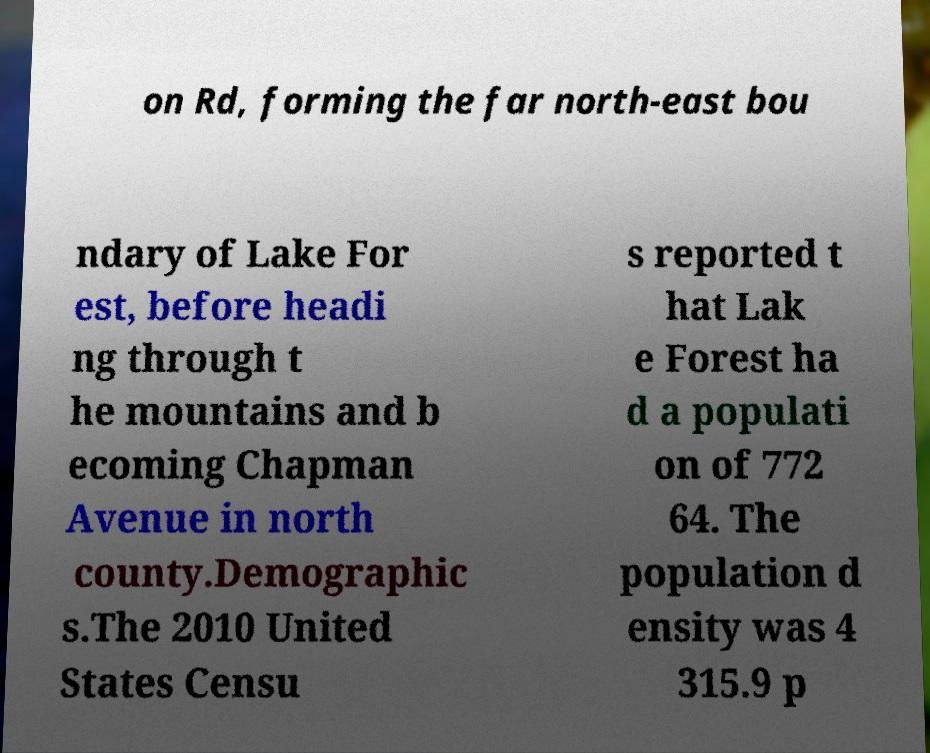Please read and relay the text visible in this image. What does it say? on Rd, forming the far north-east bou ndary of Lake For est, before headi ng through t he mountains and b ecoming Chapman Avenue in north county.Demographic s.The 2010 United States Censu s reported t hat Lak e Forest ha d a populati on of 772 64. The population d ensity was 4 315.9 p 